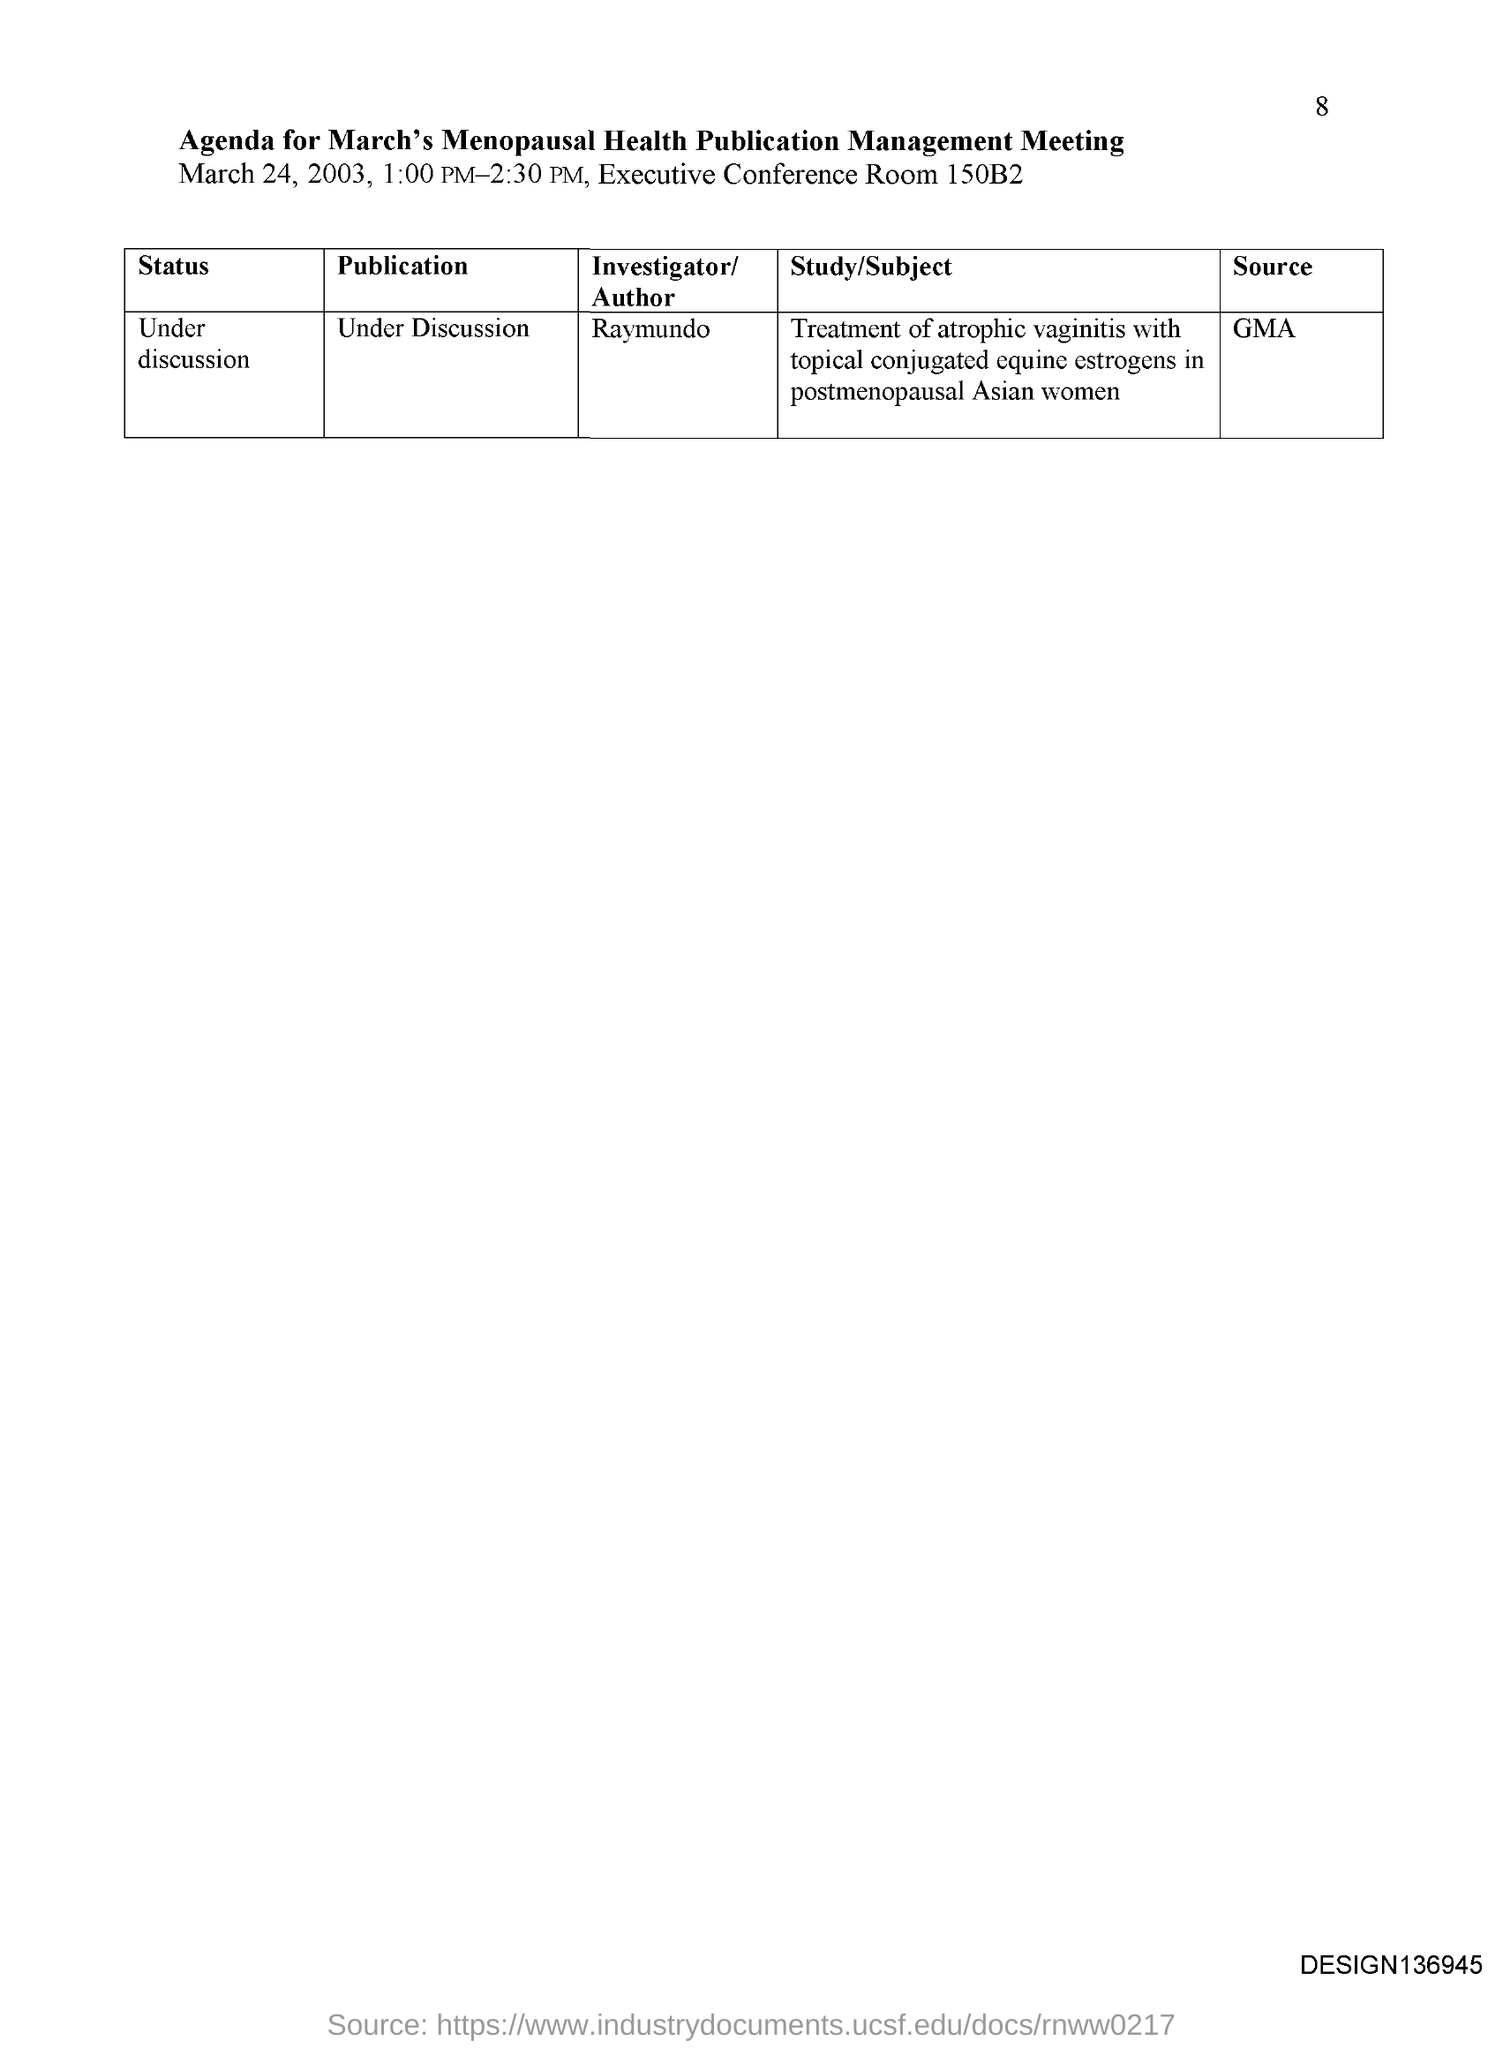When is the meeting held?
Offer a terse response. March 24, 2003. Where is the meeting held?
Provide a succinct answer. EXECUTIVE CONFERENCE ROOM 150B2. What time is the meeting held?
Your response must be concise. 1:00 PM-2:30 PM. What is the source?
Offer a terse response. GMA. 